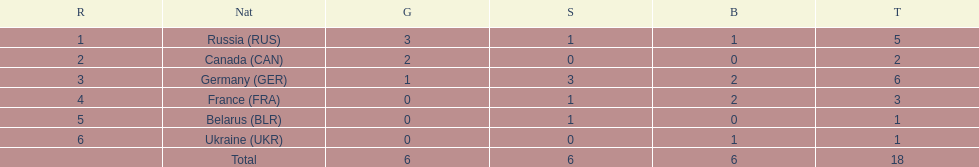How many silver medals did belarus win? 1. 